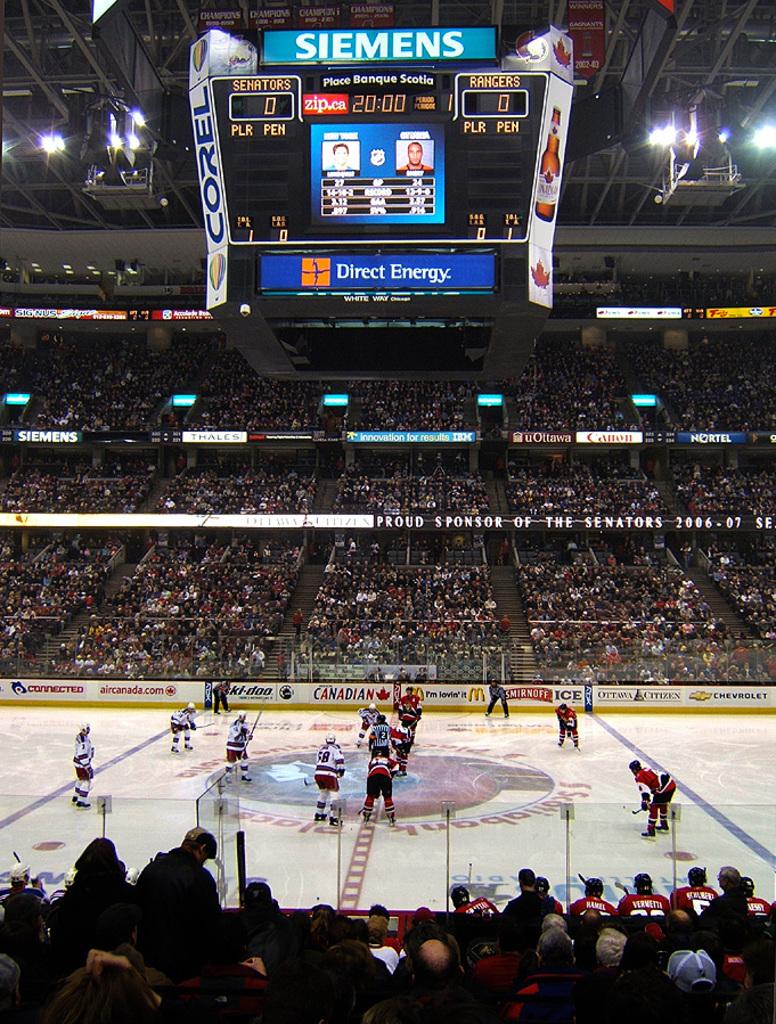How much time is left in the period?
Offer a terse response. 20:00. What is the score?
Offer a terse response. 0-0. 